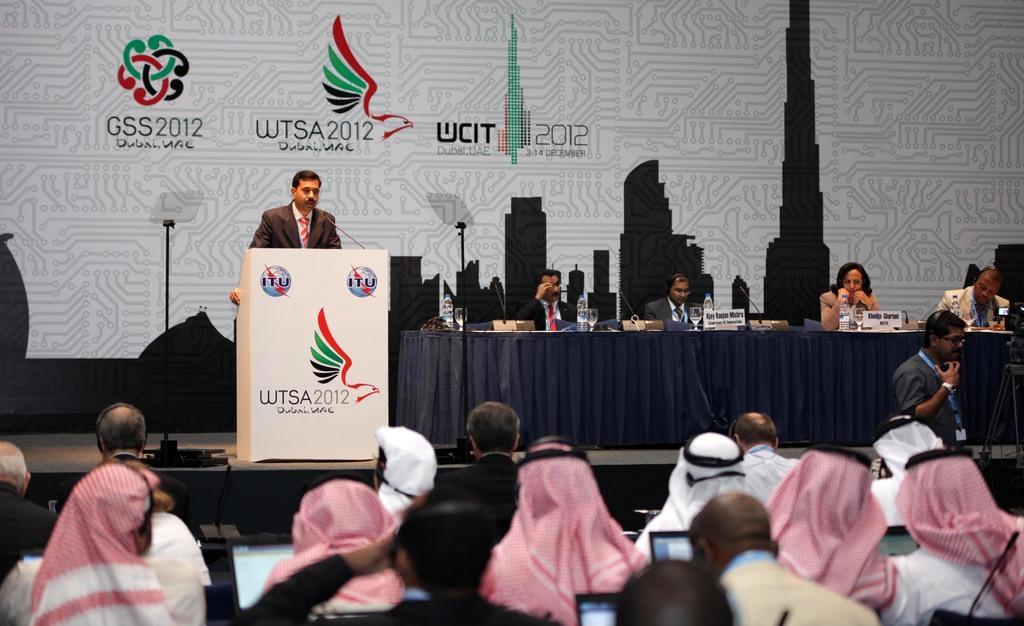Please provide a concise description of this image. This picture is clicked in the conference hall. At the bottom of the picture, we see people sitting on the chairs and they are operating the laptops. In front of them, we see a man in brown blazer is standing and he is talking on the microphone. In front of him, we see a podium. Beside him, we see four people are sitting on the chairs. In front of them, we see a table which is covered with a blue color sheet. On the table, we see water bottles, glasses, books, name boards and microphones. Behind them, we see a board in white color with some text written on it. 